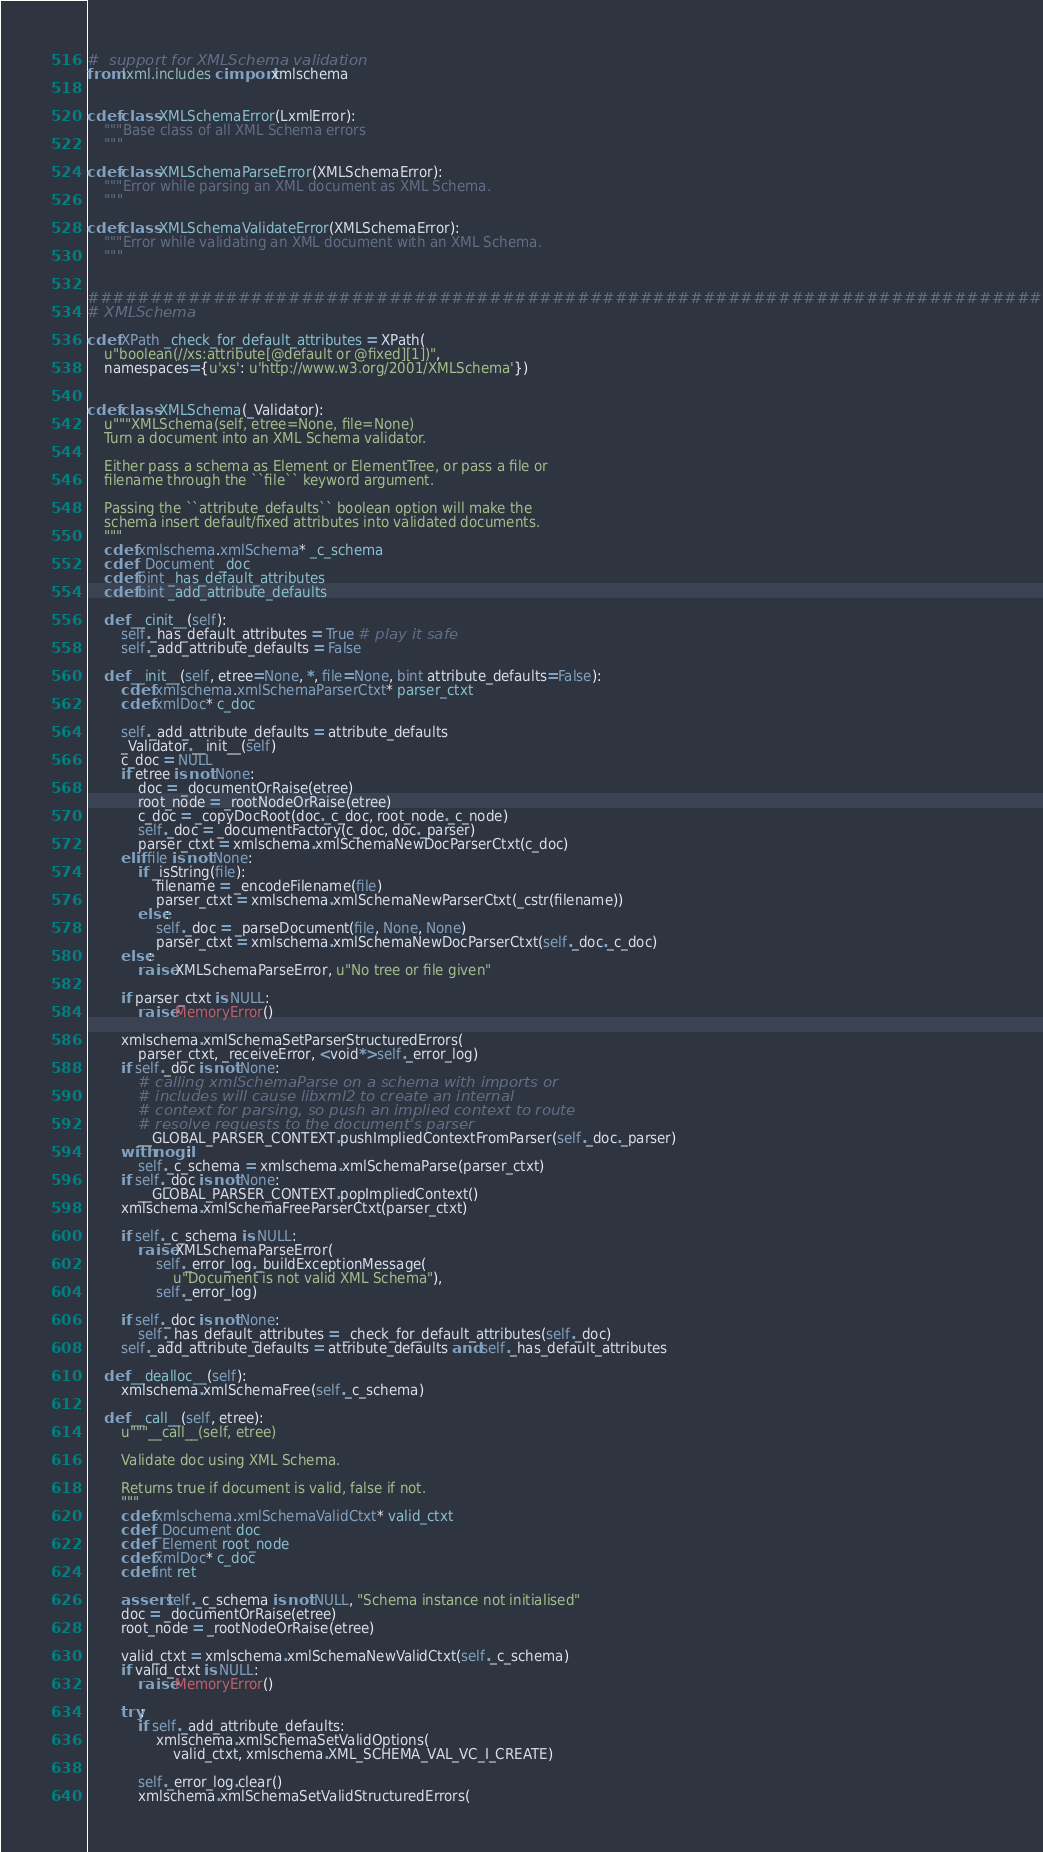Convert code to text. <code><loc_0><loc_0><loc_500><loc_500><_Cython_>#  support for XMLSchema validation
from lxml.includes cimport xmlschema


cdef class XMLSchemaError(LxmlError):
    """Base class of all XML Schema errors
    """

cdef class XMLSchemaParseError(XMLSchemaError):
    """Error while parsing an XML document as XML Schema.
    """

cdef class XMLSchemaValidateError(XMLSchemaError):
    """Error while validating an XML document with an XML Schema.
    """


################################################################################
# XMLSchema

cdef XPath _check_for_default_attributes = XPath(
    u"boolean(//xs:attribute[@default or @fixed][1])",
    namespaces={u'xs': u'http://www.w3.org/2001/XMLSchema'})


cdef class XMLSchema(_Validator):
    u"""XMLSchema(self, etree=None, file=None)
    Turn a document into an XML Schema validator.

    Either pass a schema as Element or ElementTree, or pass a file or
    filename through the ``file`` keyword argument.

    Passing the ``attribute_defaults`` boolean option will make the
    schema insert default/fixed attributes into validated documents.
    """
    cdef xmlschema.xmlSchema* _c_schema
    cdef _Document _doc
    cdef bint _has_default_attributes
    cdef bint _add_attribute_defaults

    def __cinit__(self):
        self._has_default_attributes = True # play it safe
        self._add_attribute_defaults = False

    def __init__(self, etree=None, *, file=None, bint attribute_defaults=False):
        cdef xmlschema.xmlSchemaParserCtxt* parser_ctxt
        cdef xmlDoc* c_doc

        self._add_attribute_defaults = attribute_defaults
        _Validator.__init__(self)
        c_doc = NULL
        if etree is not None:
            doc = _documentOrRaise(etree)
            root_node = _rootNodeOrRaise(etree)
            c_doc = _copyDocRoot(doc._c_doc, root_node._c_node)
            self._doc = _documentFactory(c_doc, doc._parser)
            parser_ctxt = xmlschema.xmlSchemaNewDocParserCtxt(c_doc)
        elif file is not None:
            if _isString(file):
                filename = _encodeFilename(file)
                parser_ctxt = xmlschema.xmlSchemaNewParserCtxt(_cstr(filename))
            else:
                self._doc = _parseDocument(file, None, None)
                parser_ctxt = xmlschema.xmlSchemaNewDocParserCtxt(self._doc._c_doc)
        else:
            raise XMLSchemaParseError, u"No tree or file given"

        if parser_ctxt is NULL:
            raise MemoryError()

        xmlschema.xmlSchemaSetParserStructuredErrors(
            parser_ctxt, _receiveError, <void*>self._error_log)
        if self._doc is not None:
            # calling xmlSchemaParse on a schema with imports or
            # includes will cause libxml2 to create an internal
            # context for parsing, so push an implied context to route
            # resolve requests to the document's parser
            __GLOBAL_PARSER_CONTEXT.pushImpliedContextFromParser(self._doc._parser)
        with nogil:
            self._c_schema = xmlschema.xmlSchemaParse(parser_ctxt)
        if self._doc is not None:
            __GLOBAL_PARSER_CONTEXT.popImpliedContext()
        xmlschema.xmlSchemaFreeParserCtxt(parser_ctxt)

        if self._c_schema is NULL:
            raise XMLSchemaParseError(
                self._error_log._buildExceptionMessage(
                    u"Document is not valid XML Schema"),
                self._error_log)

        if self._doc is not None:
            self._has_default_attributes = _check_for_default_attributes(self._doc)
        self._add_attribute_defaults = attribute_defaults and self._has_default_attributes

    def __dealloc__(self):
        xmlschema.xmlSchemaFree(self._c_schema)

    def __call__(self, etree):
        u"""__call__(self, etree)

        Validate doc using XML Schema.

        Returns true if document is valid, false if not.
        """
        cdef xmlschema.xmlSchemaValidCtxt* valid_ctxt
        cdef _Document doc
        cdef _Element root_node
        cdef xmlDoc* c_doc
        cdef int ret

        assert self._c_schema is not NULL, "Schema instance not initialised"
        doc = _documentOrRaise(etree)
        root_node = _rootNodeOrRaise(etree)

        valid_ctxt = xmlschema.xmlSchemaNewValidCtxt(self._c_schema)
        if valid_ctxt is NULL:
            raise MemoryError()

        try:
            if self._add_attribute_defaults:
                xmlschema.xmlSchemaSetValidOptions(
                    valid_ctxt, xmlschema.XML_SCHEMA_VAL_VC_I_CREATE)

            self._error_log.clear()
            xmlschema.xmlSchemaSetValidStructuredErrors(</code> 